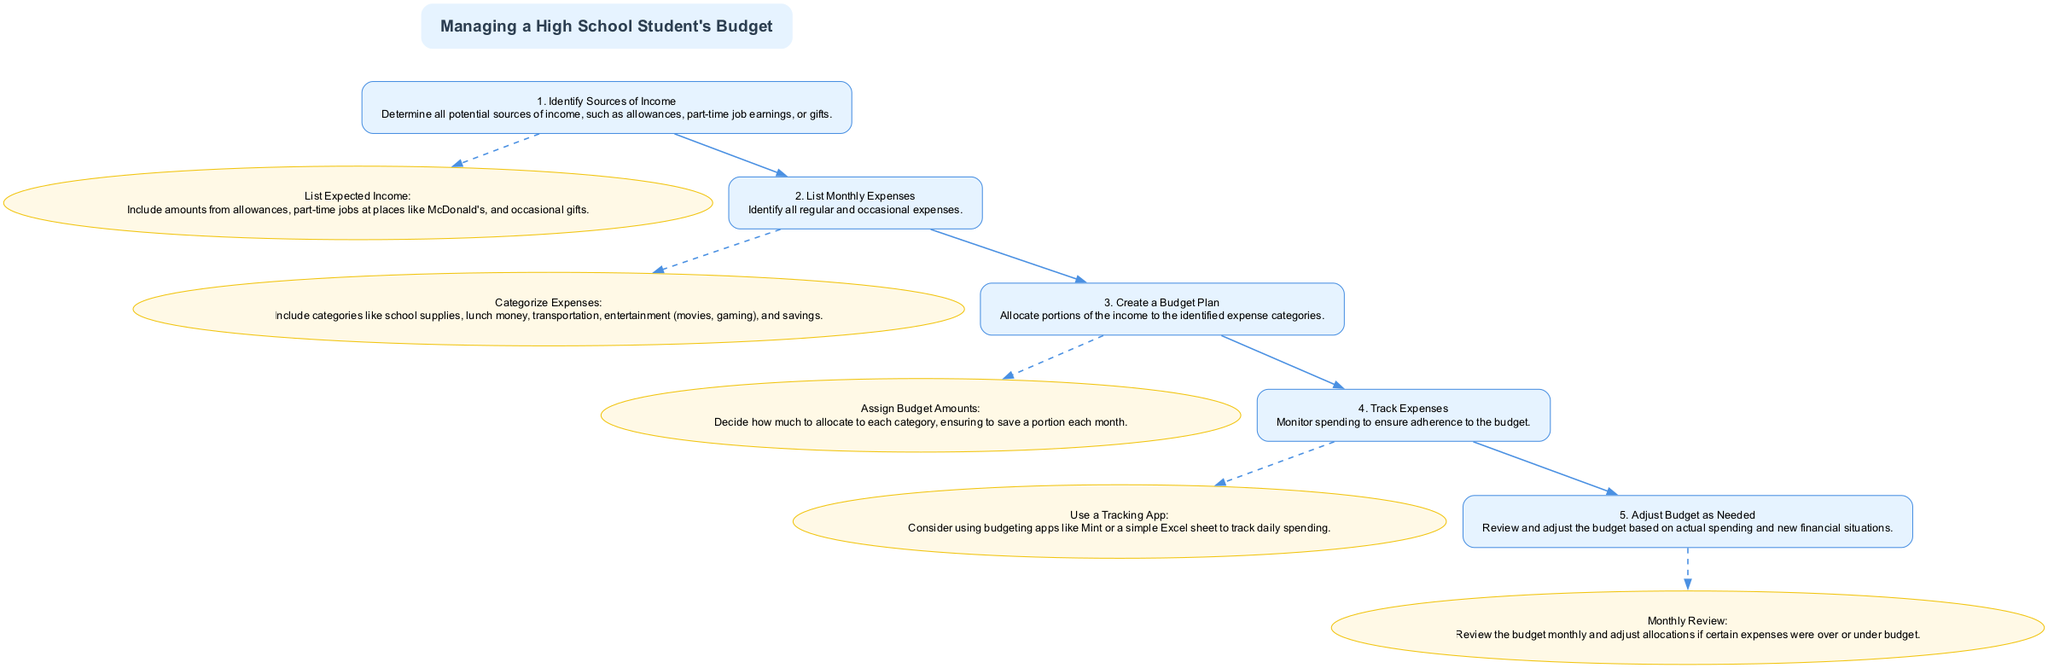What is the title of the diagram? The title of the diagram is indicated at the top in a larger font size. It clearly states "Managing a High School Student's Budget."
Answer: Managing a High School Student's Budget How many steps are listed in the diagram? The diagram lists a total of five steps, each numbered sequentially from 1 to 5. This can be counted directly from the steps in the flowchart.
Answer: 5 What is the description of step 3? The description for step 3 can be found directly under its title in the flowchart. It states, "Allocate portions of the income to the identified expense categories."
Answer: Allocate portions of the income to the identified expense categories Which step comes after tracking expenses? To find the step that follows tracking expenses, we look at the connections in the flowchart. Step 4 is "Track Expenses," and the next step is step 5, which is "Adjust Budget as Needed."
Answer: Adjust Budget as Needed What is the action associated with step 2? Each step in the diagram has associated actions listed beneath it. For step 2, the action is "Categorize Expenses: Include categories like school supplies, lunch money, transportation, entertainment (movies, gaming), and savings."
Answer: Categorize Expenses: Include categories like school supplies, lunch money, transportation, entertainment (movies, gaming), and savings What is the relationship between step 1 and step 2? The relationship can be identified by examining the flow of the diagram. Step 1 leads into step 2 as indicated by the arrows connecting them, meaning that step 2 follows directly after completing step 1.
Answer: Step 1 leads into step 2 What happens in the monthly review process in step 5? Step 5 describes the action "Monthly Review," which indicates that after tracking expenses, a review of the budget is performed monthly to adjust allocations based on actual spending. This reflects the need for adaptability in the budget management process.
Answer: Review the budget monthly and adjust allocations How does one track expenses according to step 4? The action taken in step 4 is to use a tracking app or a simple Excel sheet for monitoring expenses. This detail is explicitly outlined in the actions related to step 4.
Answer: Use a Tracking App 